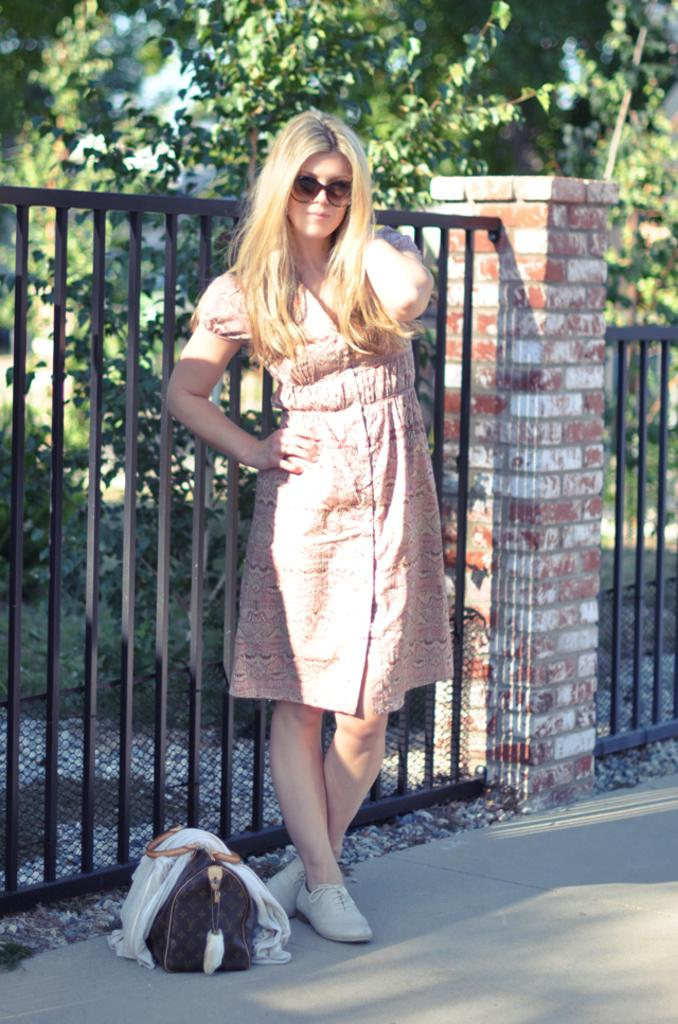Who is present in the image? There is a woman in the image. What is the woman wearing? The woman is wearing spectacles. What can be seen in the background of the image? There is a fence and trees visible in the image. What object is the woman holding or carrying? There is a bag in the image. What type of pain is the woman experiencing in the image? There is no indication in the image that the woman is experiencing any pain. 